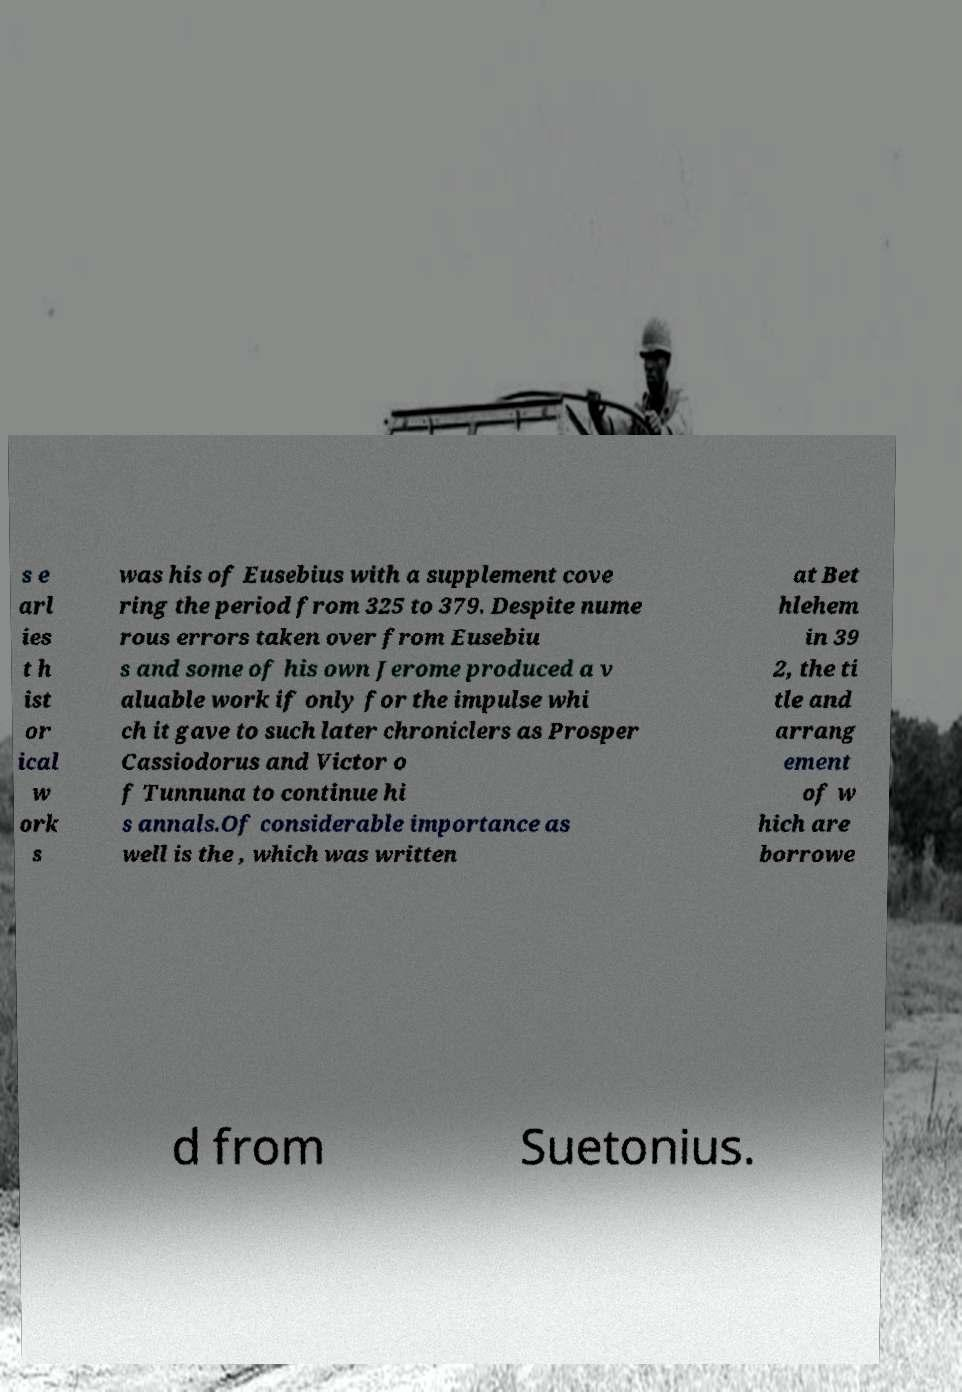Could you extract and type out the text from this image? s e arl ies t h ist or ical w ork s was his of Eusebius with a supplement cove ring the period from 325 to 379. Despite nume rous errors taken over from Eusebiu s and some of his own Jerome produced a v aluable work if only for the impulse whi ch it gave to such later chroniclers as Prosper Cassiodorus and Victor o f Tunnuna to continue hi s annals.Of considerable importance as well is the , which was written at Bet hlehem in 39 2, the ti tle and arrang ement of w hich are borrowe d from Suetonius. 